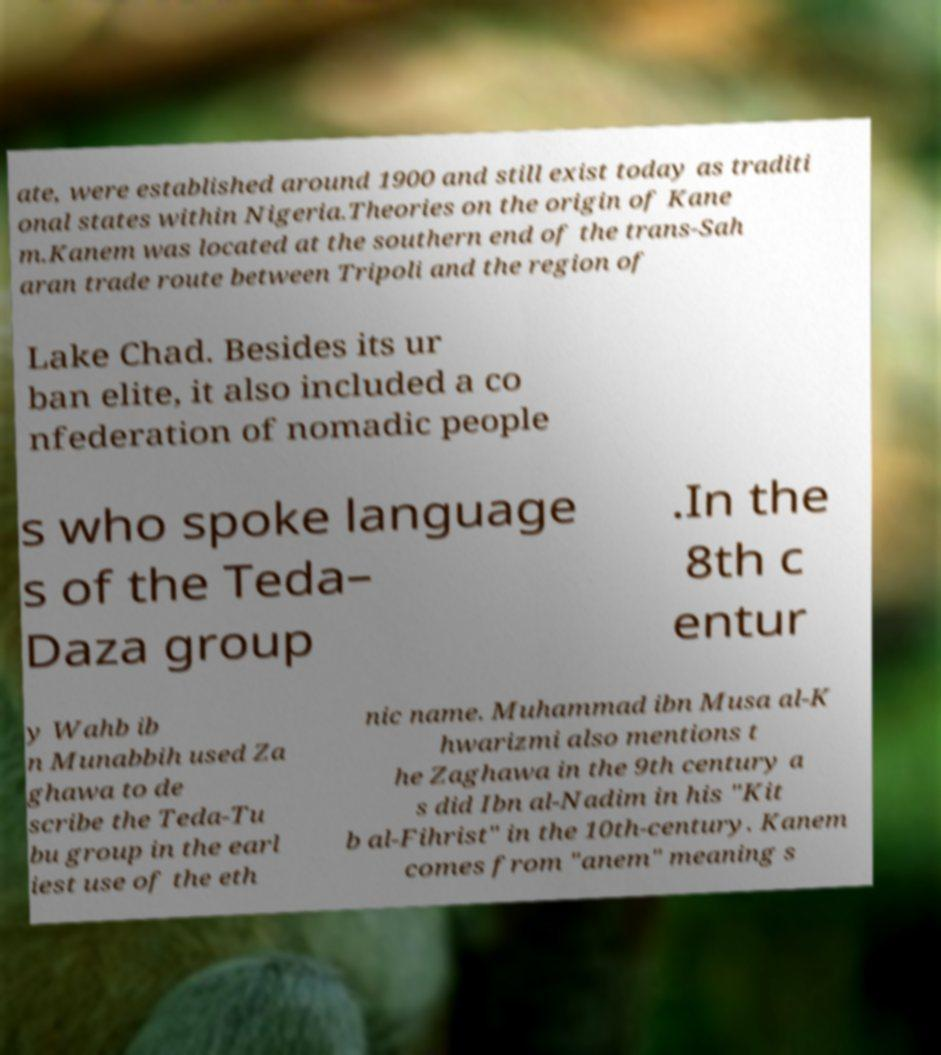I need the written content from this picture converted into text. Can you do that? ate, were established around 1900 and still exist today as traditi onal states within Nigeria.Theories on the origin of Kane m.Kanem was located at the southern end of the trans-Sah aran trade route between Tripoli and the region of Lake Chad. Besides its ur ban elite, it also included a co nfederation of nomadic people s who spoke language s of the Teda– Daza group .In the 8th c entur y Wahb ib n Munabbih used Za ghawa to de scribe the Teda-Tu bu group in the earl iest use of the eth nic name. Muhammad ibn Musa al-K hwarizmi also mentions t he Zaghawa in the 9th century a s did Ibn al-Nadim in his "Kit b al-Fihrist" in the 10th-century. Kanem comes from "anem" meaning s 